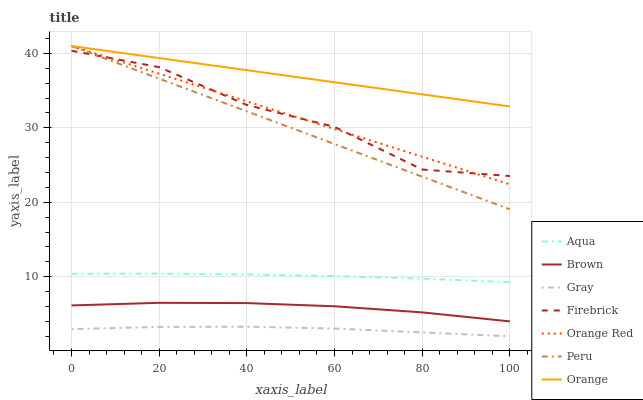Does Gray have the minimum area under the curve?
Answer yes or no. Yes. Does Orange have the maximum area under the curve?
Answer yes or no. Yes. Does Firebrick have the minimum area under the curve?
Answer yes or no. No. Does Firebrick have the maximum area under the curve?
Answer yes or no. No. Is Orange Red the smoothest?
Answer yes or no. Yes. Is Firebrick the roughest?
Answer yes or no. Yes. Is Gray the smoothest?
Answer yes or no. No. Is Gray the roughest?
Answer yes or no. No. Does Gray have the lowest value?
Answer yes or no. Yes. Does Firebrick have the lowest value?
Answer yes or no. No. Does Orange Red have the highest value?
Answer yes or no. Yes. Does Firebrick have the highest value?
Answer yes or no. No. Is Brown less than Firebrick?
Answer yes or no. Yes. Is Firebrick greater than Gray?
Answer yes or no. Yes. Does Orange Red intersect Orange?
Answer yes or no. Yes. Is Orange Red less than Orange?
Answer yes or no. No. Is Orange Red greater than Orange?
Answer yes or no. No. Does Brown intersect Firebrick?
Answer yes or no. No. 